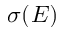<formula> <loc_0><loc_0><loc_500><loc_500>\sigma ( E )</formula> 